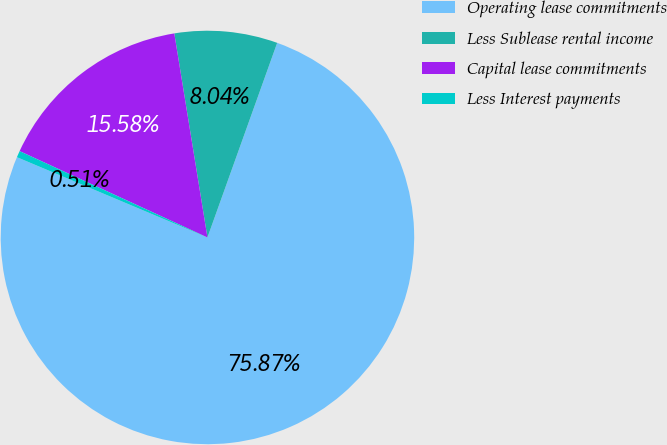Convert chart to OTSL. <chart><loc_0><loc_0><loc_500><loc_500><pie_chart><fcel>Operating lease commitments<fcel>Less Sublease rental income<fcel>Capital lease commitments<fcel>Less Interest payments<nl><fcel>75.87%<fcel>8.04%<fcel>15.58%<fcel>0.51%<nl></chart> 